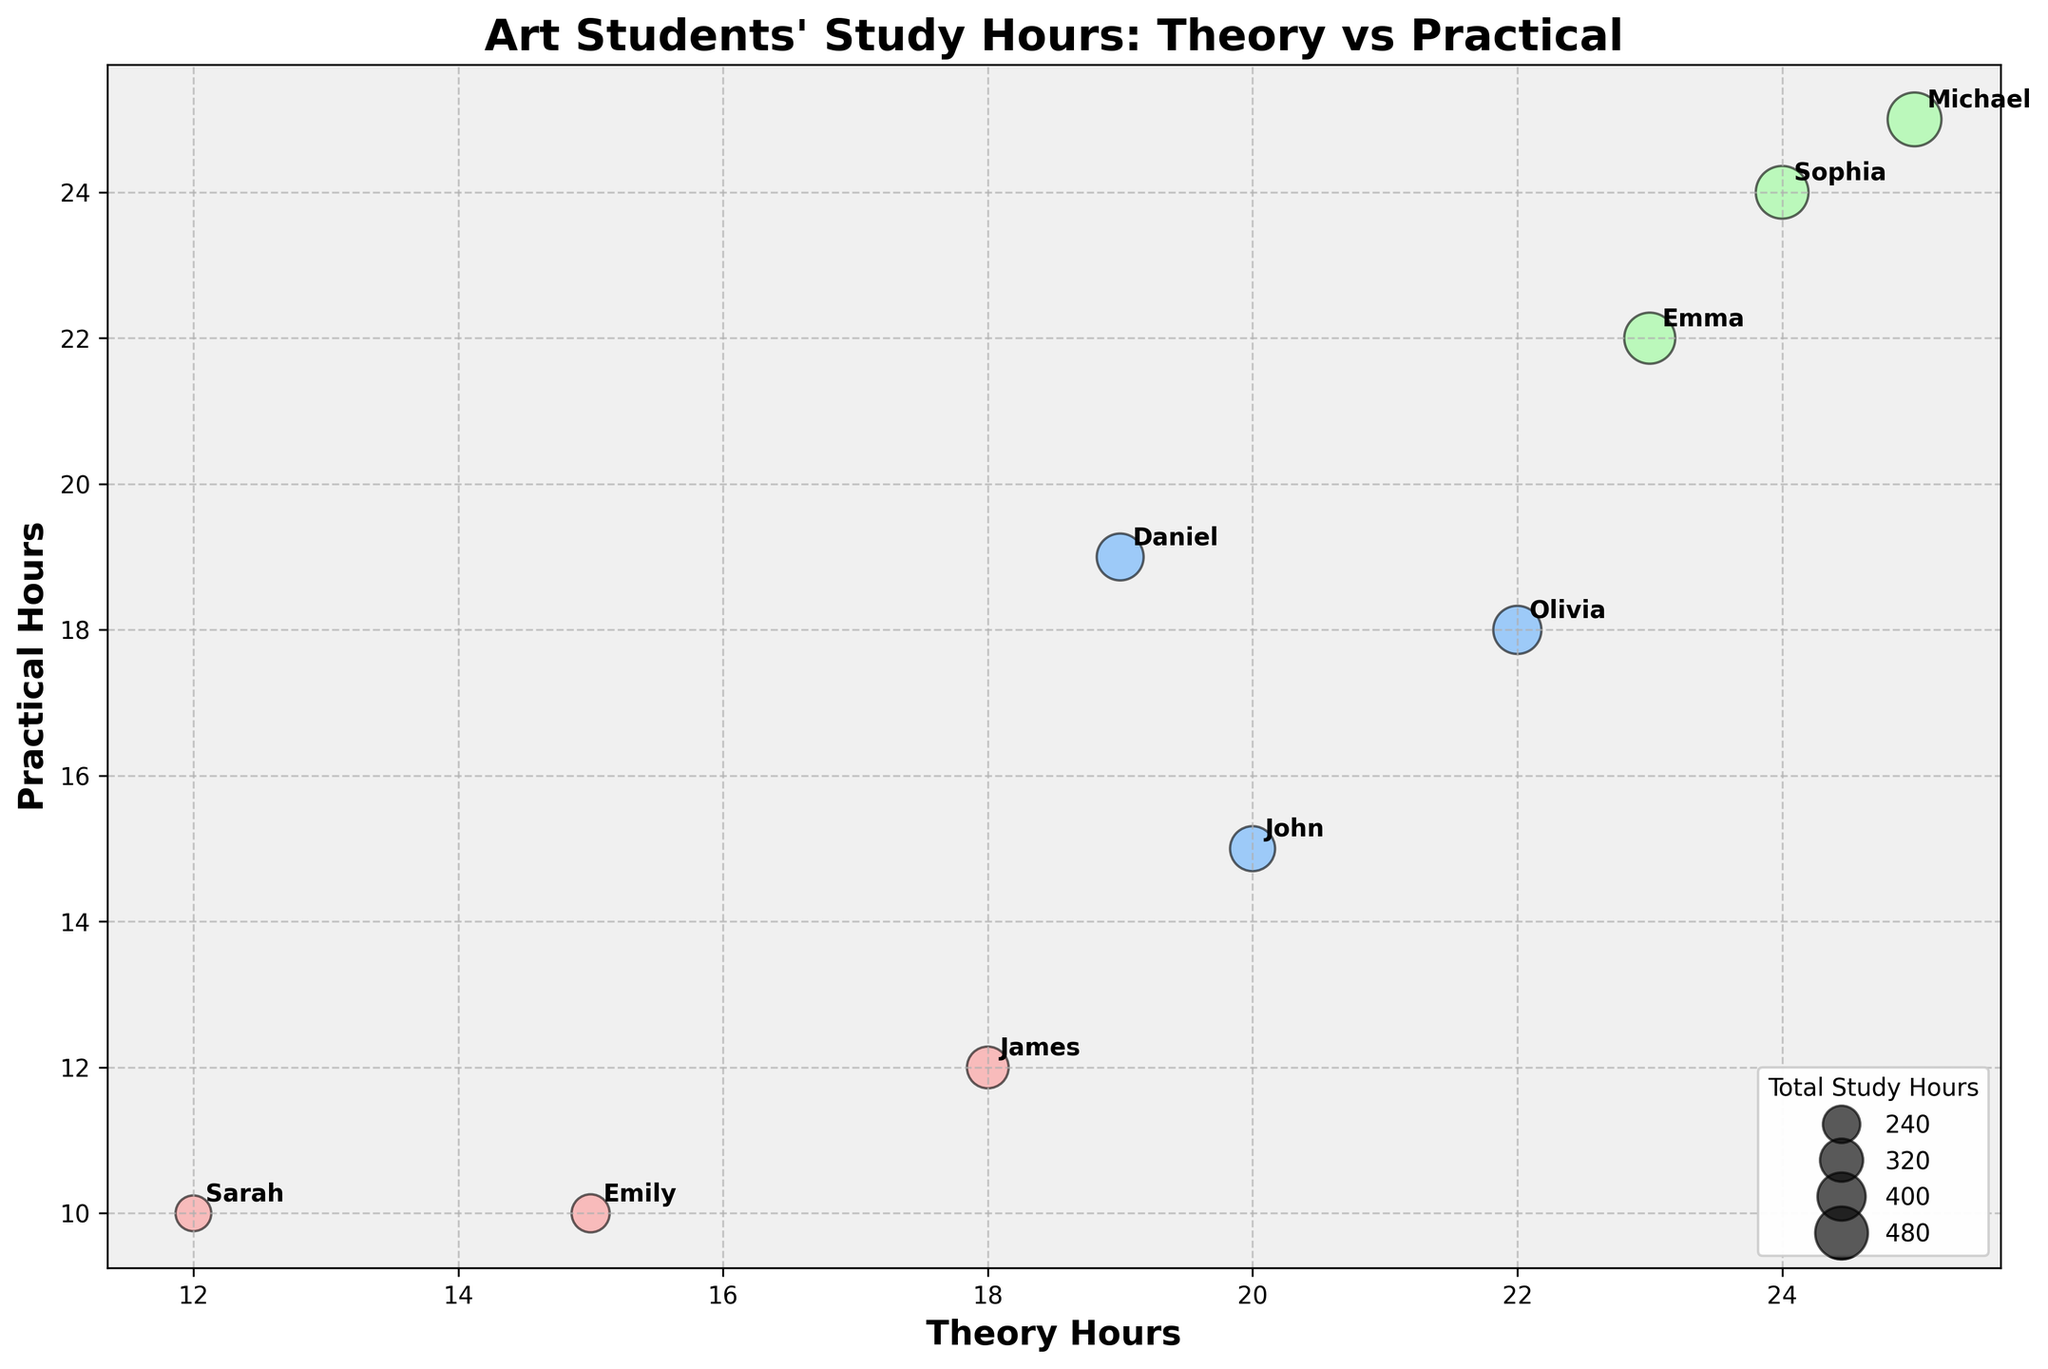what is the title of the chart? The title is usually located at the top of the figure. In this chart, it is displayed prominently in larger text.
Answer: Art Students' Study Hours: Theory vs Practical What are the labels on the x-axis and y-axis? The labels can be found adjacent to the respective axes. The x-axis label denotes the horizontal axis, while the y-axis label denotes the vertical axis.
Answer: Theory Hours (x-axis) and Practical Hours (y-axis) How many students' data points are shown in the chart? Each data point represents a student’s total study hours, with theory hours as the x-axis and practical hours as the y-axis. Counting the points gives the total number of students.
Answer: 9 Which student has the highest total study hours and what are those hours? The size of each bubble denotes the total study hours, with larger bubbles indicating more hours. Identify the largest bubble to find the student with the most study hours.
Answer: Michael, 50 study hours What color represents Second Year students? The legend at the top left specifies which color corresponds to each academic year.
Answer: A shade of blue Who has more theory hours, Emma or John, and by how many hours? Compare the x-coordinates for Emma and John. The x-coordinate represents theory hours. Subtract the smaller value from the larger to find the difference.
Answer: Emma by 3 hours Are there any students with an equal amount of theory and practical hours? For equal theory and practical hours, the data point must lie on the line y = x. Check if any bubbles lie along this diagonal.
Answer: Yes, Michael and Sophia have equal theory and practical hours Which year group shows the most diverse study hours in terms of bubble size? Bubble size indicates total study hours, and diversity can be assessed by variability in size for each year group. First Year, Second Year, and Third Year bubbles can be visually compared or explained with data.
Answer: Second Year How does the variation in practical hours differ between First Year and Third Year students? Practical hours are represented by the y-coordinates of points. Observing the spread of these coordinates for both groups will show the variation.
Answer: Third Year students show greater variation in practical hours What can you infer about the relationship between theory and practical hours for the students? Assess the positioning of the bubbles to see if there’s any visible trend or correlation pattern between theory and practical hours.
Answer: Generally positive correlation; as theory hours increase, practical hours also tend to increase 